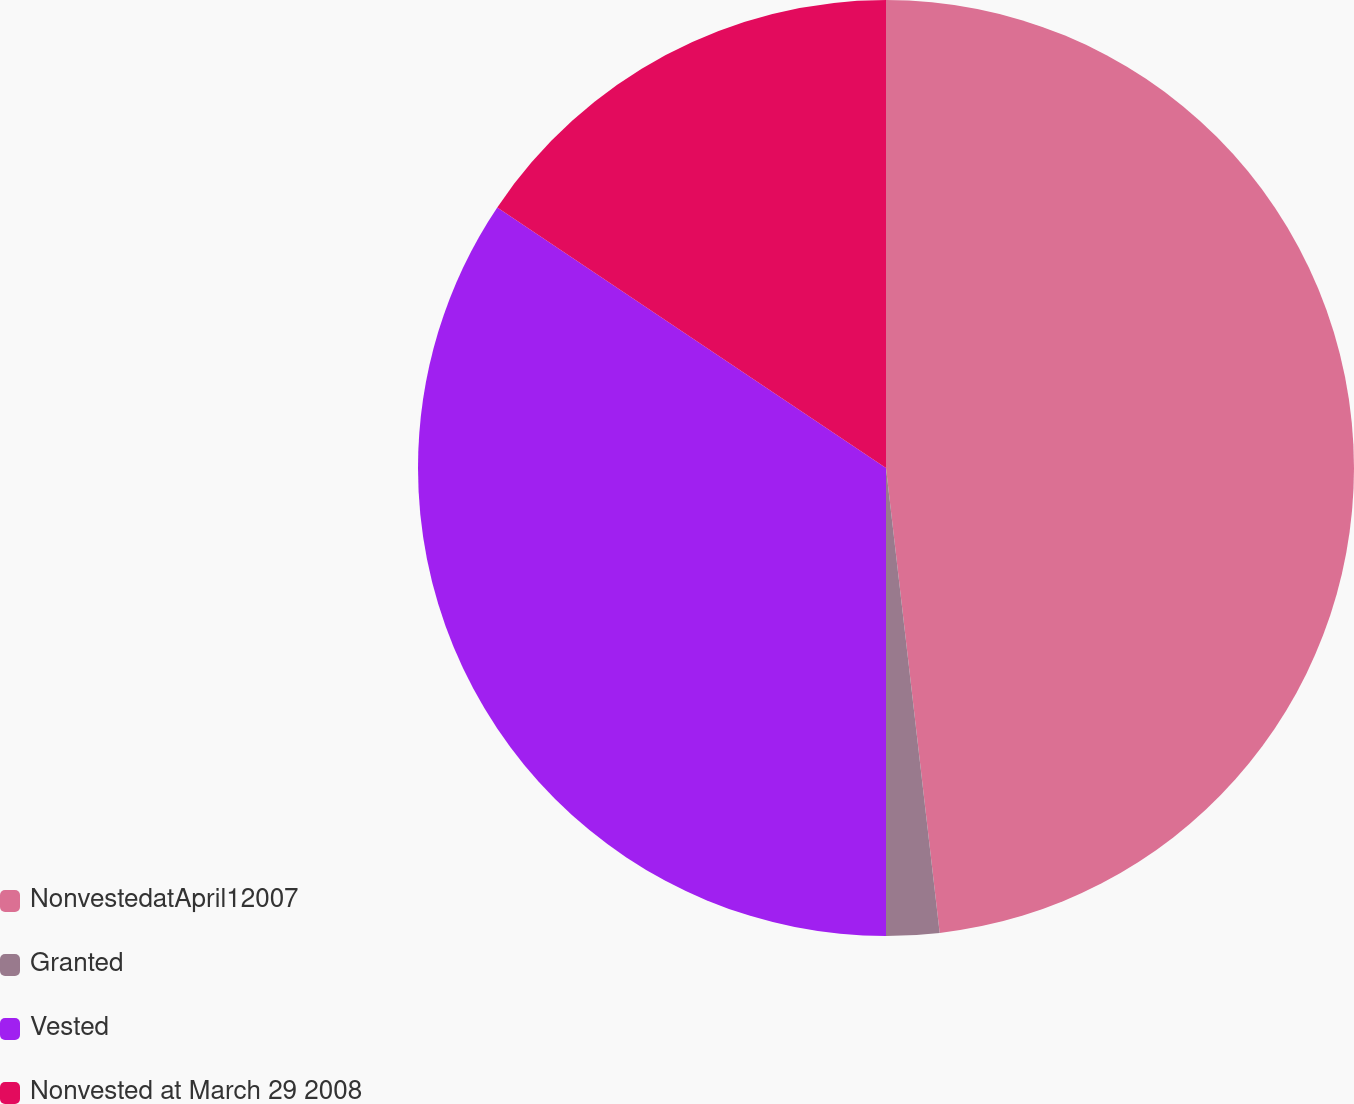Convert chart to OTSL. <chart><loc_0><loc_0><loc_500><loc_500><pie_chart><fcel>NonvestedatApril12007<fcel>Granted<fcel>Vested<fcel>Nonvested at March 29 2008<nl><fcel>48.17%<fcel>1.83%<fcel>34.4%<fcel>15.6%<nl></chart> 